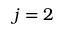<formula> <loc_0><loc_0><loc_500><loc_500>j = 2</formula> 